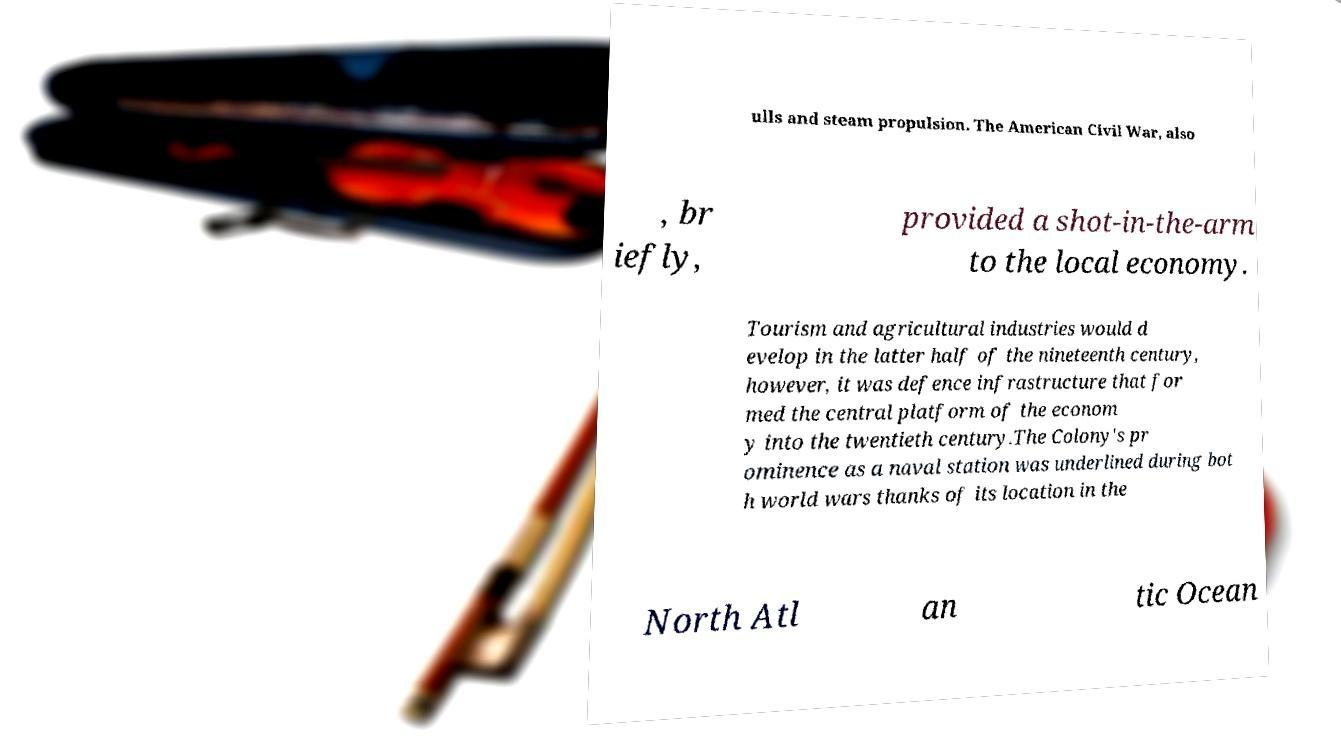Please read and relay the text visible in this image. What does it say? ulls and steam propulsion. The American Civil War, also , br iefly, provided a shot-in-the-arm to the local economy. Tourism and agricultural industries would d evelop in the latter half of the nineteenth century, however, it was defence infrastructure that for med the central platform of the econom y into the twentieth century.The Colony's pr ominence as a naval station was underlined during bot h world wars thanks of its location in the North Atl an tic Ocean 